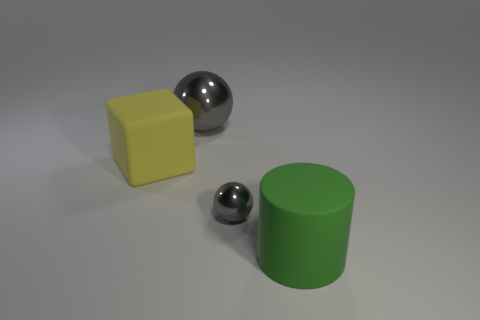Add 4 large metallic balls. How many objects exist? 8 Subtract all cylinders. How many objects are left? 3 Add 4 purple metal balls. How many purple metal balls exist? 4 Subtract 0 purple cubes. How many objects are left? 4 Subtract all blocks. Subtract all gray shiny balls. How many objects are left? 1 Add 4 tiny gray shiny balls. How many tiny gray shiny balls are left? 5 